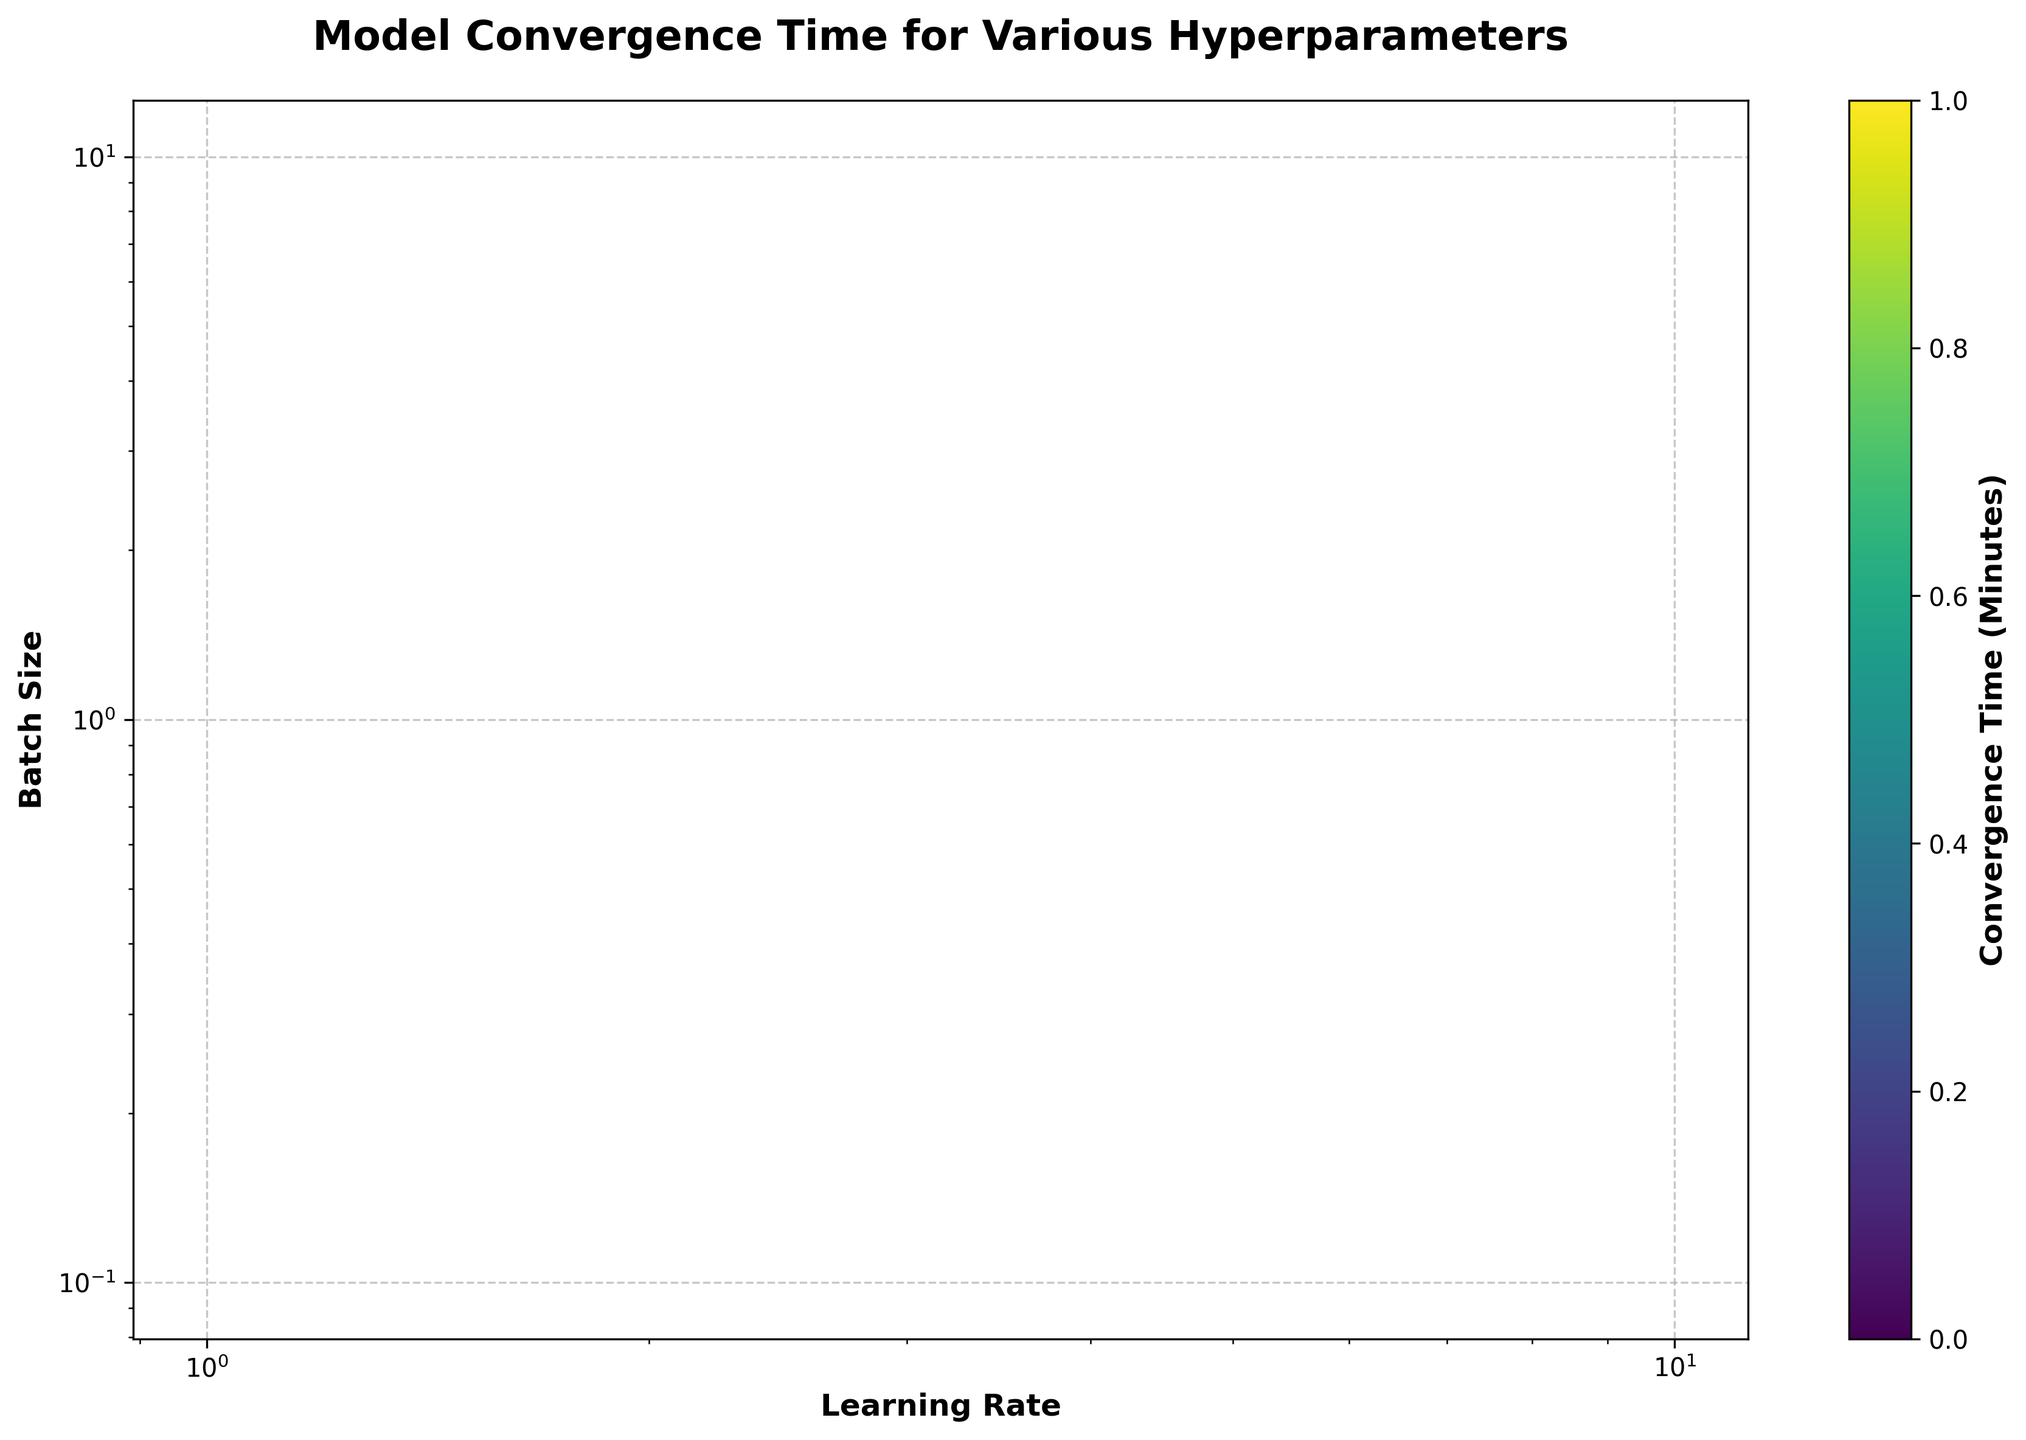What is the title of the figure? The title is usually displayed at the top of the figure. In this case, it reads "Model Convergence Time for Various Hyperparameters".
Answer: Model Convergence Time for Various Hyperparameters What are the x-axis and y-axis labels? The x-axis and y-axis labels are found on the horizontal and vertical axes, respectively. They read "Learning Rate" and "Batch Size".
Answer: Learning Rate, Batch Size What color represents the convergence time on the hexbin plot? The color representing the convergence time can be seen in the color gradient on the hexbin cells and described by the color bar. The color gradient ranges from light yellow to dark purple, indicating variations in convergence times.
Answer: Varies from light yellow to dark purple Which part of the plot shows the shortest convergence times? The shortest convergence times would be represented by the lightest color (near yellow) in the plot.
Answer: Light yellow areas Does the figure show a logarithmic scale for the axes? The figure uses a logarithmic scale for the x-axis (Learning Rate) and the y-axis (Batch Size), with ticks indicating exponential increments.
Answer: Yes Where are the highest convergence times observed on the plot? The highest convergence times can be identified by the darkest color (near black/purple) in the plot. These regions correspond to certain combinations of learning rates and batch sizes.
Answer: Dark purple areas Do higher learning rates generally lead to shorter or longer convergence times based on the color distribution? Based on the color distribution, higher learning rates (towards the right on the x-axis) tend to have darker colors, indicating longer convergence times.
Answer: Longer convergence times What is the purpose of the color bar on the right side of the plot? The color bar serves as a legend to the hexbin plot, indicating the range of convergence times represented by the different colors.
Answer: To indicate convergence time range Is there a visible pattern between batch size and convergence time? Yes, by observing the color changes along the y-axis, one can notice that smaller batch sizes (lower on the y-axis) generally have lighter colors, indicating shorter convergence times, and vice versa.
Answer: Smaller batch sizes generally lead to shorter convergence times 